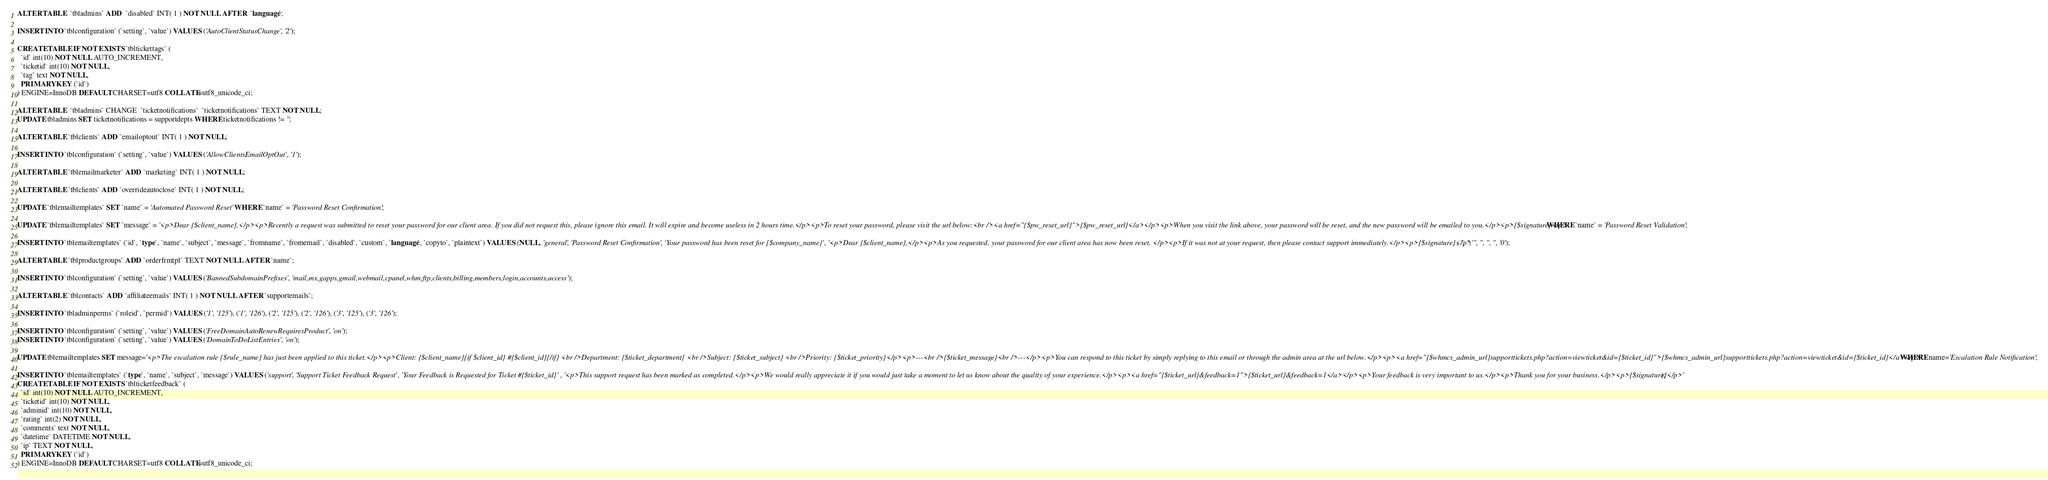Convert code to text. <code><loc_0><loc_0><loc_500><loc_500><_SQL_>ALTER TABLE  `tbladmins` ADD  `disabled` INT( 1 ) NOT NULL AFTER  `language`;

INSERT INTO `tblconfiguration` (`setting`, `value`) VALUES ('AutoClientStatusChange', '2');

CREATE TABLE IF NOT EXISTS `tbltickettags` (
  `id` int(10) NOT NULL AUTO_INCREMENT,
  `ticketid` int(10) NOT NULL,
  `tag` text NOT NULL,
  PRIMARY KEY (`id`)
) ENGINE=InnoDB DEFAULT CHARSET=utf8 COLLATE=utf8_unicode_ci;

ALTER TABLE  `tbladmins` CHANGE  `ticketnotifications`  `ticketnotifications` TEXT NOT NULL;
UPDATE tbladmins SET ticketnotifications = supportdepts WHERE ticketnotifications != '';

ALTER TABLE `tblclients` ADD `emailoptout` INT( 1 ) NOT NULL;

INSERT INTO `tblconfiguration` (`setting`, `value`) VALUES ('AllowClientsEmailOptOut', '1');

ALTER TABLE `tblemailmarketer` ADD `marketing` INT( 1 ) NOT NULL;

ALTER TABLE `tblclients` ADD `overrideautoclose` INT( 1 ) NOT NULL;

UPDATE `tblemailtemplates` SET `name` = 'Automated Password Reset' WHERE `name` = 'Password Reset Confirmation';

UPDATE `tblemailtemplates` SET `message` = '<p>Dear {$client_name},</p><p>Recently a request was submitted to reset your password for our client area. If you did not request this, please ignore this email. It will expire and become useless in 2 hours time.</p><p>To reset your password, please visit the url below:<br /><a href="{$pw_reset_url}">{$pw_reset_url}</a></p><p>When you visit the link above, your password will be reset, and the new password will be emailed to you.</p><p>{$signature}</p>' WHERE `name` = 'Password Reset Validation';

INSERT INTO `tblemailtemplates` (`id`, `type`, `name`, `subject`, `message`, `fromname`, `fromemail`, `disabled`, `custom`, `language`, `copyto`, `plaintext`) VALUES (NULL, 'general', 'Password Reset Confirmation', 'Your password has been reset for {$company_name}', '<p>Dear {$client_name},</p><p>As you requested, your password for our client area has now been reset. </p><p>If it was not at your request, then please contact support immediately.</p><p>{$signature}</p>', '', '', '', '', '', '', '0');

ALTER TABLE `tblproductgroups` ADD `orderfrmtpl` TEXT NOT NULL AFTER `name`;

INSERT INTO `tblconfiguration` (`setting`, `value`) VALUES ('BannedSubdomainPrefixes', 'mail,mx,gapps,gmail,webmail,cpanel,whm,ftp,clients,billing,members,login,accounts,access');

ALTER TABLE `tblcontacts` ADD `affiliateemails` INT( 1 ) NOT NULL AFTER `supportemails`;

INSERT INTO `tbladminperms` (`roleid`, `permid`) VALUES ('1', '125'), ('1', '126'), ('2', '125'), ('2', '126'), ('3', '125'), ('3', '126');

INSERT INTO `tblconfiguration` (`setting`, `value`) VALUES ('FreeDomainAutoRenewRequiresProduct', 'on');
INSERT INTO `tblconfiguration` (`setting`, `value`) VALUES ('DomainToDoListEntries', 'on');

UPDATE tblemailtemplates SET message='<p>The escalation rule {$rule_name} has just been applied to this ticket.</p><p>Client: {$client_name}{if $client_id} #{$client_id}{/if} <br />Department: {$ticket_department} <br />Subject: {$ticket_subject} <br />Priority: {$ticket_priority}</p><p>---<br />{$ticket_message}<br />---</p><p>You can respond to this ticket by simply replying to this email or through the admin area at the url below.</p><p><a href="{$whmcs_admin_url}supporttickets.php?action=viewticket&id={$ticket_id}">{$whmcs_admin_url}supporttickets.php?action=viewticket&id={$ticket_id}</a></p>' WHERE name='Escalation Rule Notification';

INSERT INTO `tblemailtemplates` (`type`, `name`, `subject`, `message`) VALUES ('support', 'Support Ticket Feedback Request', 'Your Feedback is Requested for Ticket #{$ticket_id}', '<p>This support request has been marked as completed.</p><p>We would really appreciate it if you would just take a moment to let us know about the quality of your experience.</p><p><a href="{$ticket_url}&feedback=1">{$ticket_url}&feedback=1</a></p><p>Your feedback is very important to us.</p><p>Thank you for your business.</p><p>{$signature}</p>');
CREATE TABLE IF NOT EXISTS `tblticketfeedback` (
  `id` int(10) NOT NULL AUTO_INCREMENT,
  `ticketid` int(10) NOT NULL,
  `adminid` int(10) NOT NULL,
  `rating` int(2) NOT NULL,
  `comments` text NOT NULL,
  `datetime` DATETIME NOT NULL,
  `ip` TEXT NOT NULL,
  PRIMARY KEY (`id`)
) ENGINE=InnoDB DEFAULT CHARSET=utf8 COLLATE=utf8_unicode_ci;
</code> 